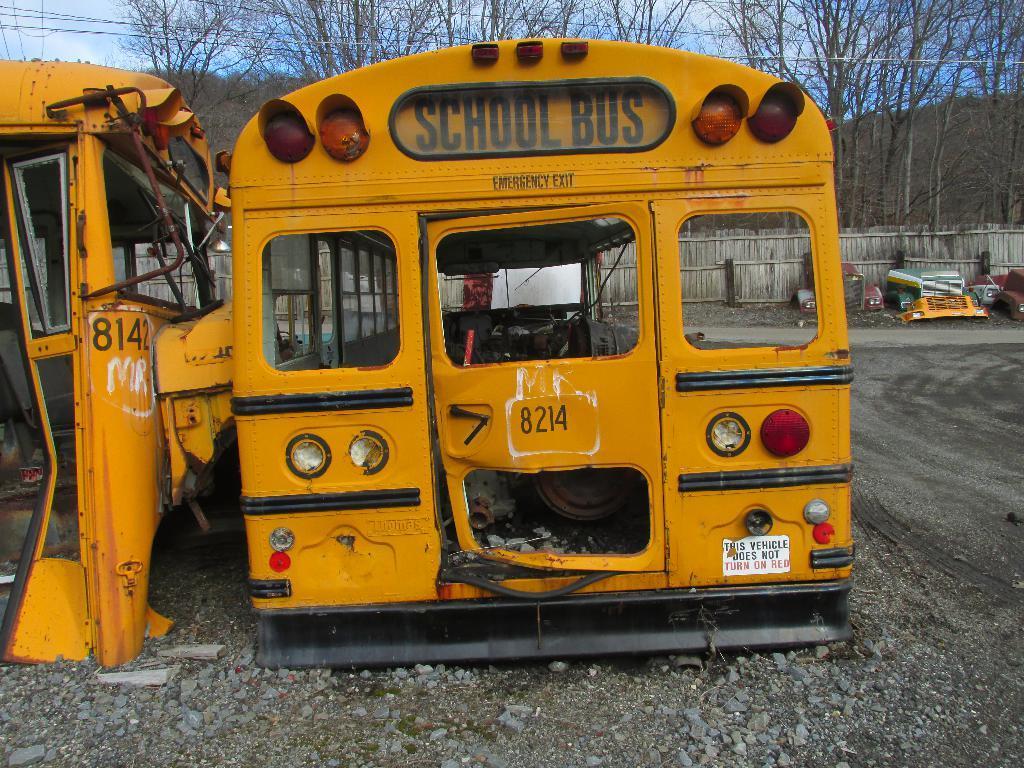Please provide a concise description of this image. In this image we can see different parts of the vehicles and some stones on the ground, we can see there are some trees, mountains and the wall, in the background we can see the sky. 